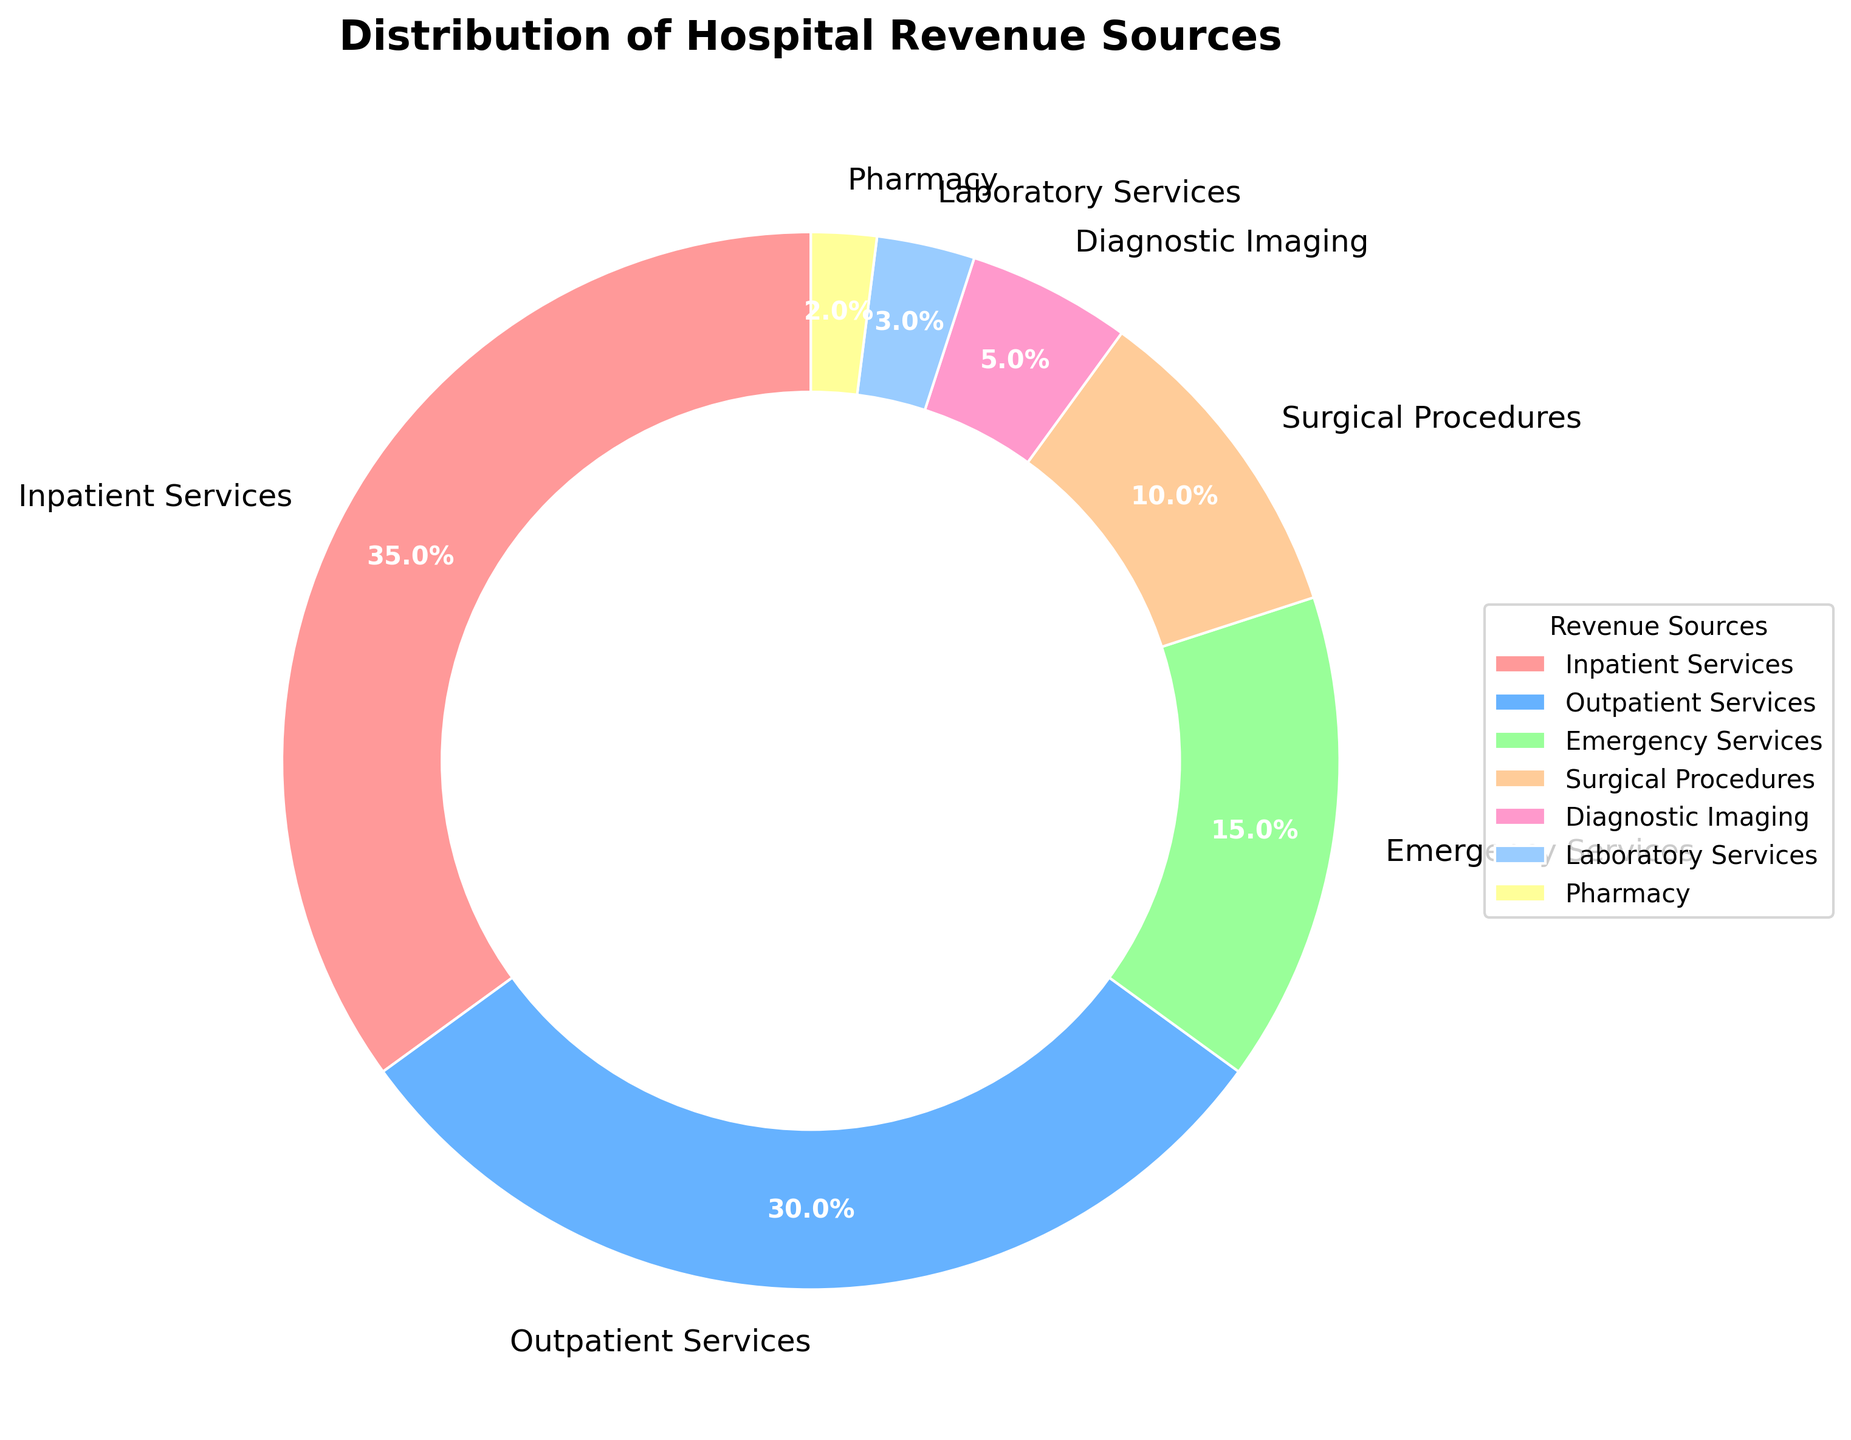What percentage of hospital revenue comes from inpatient services and surgical procedures combined? To find the combined percentage of revenue from inpatient services and surgical procedures, add their individual percentages: 35% (inpatient services) + 10% (surgical procedures) = 45%.
Answer: 45% Which revenue source contributes less to the total revenue: laboratory services or pharmacy? The pie chart shows that laboratory services contribute 3% and pharmacy contributes 2%. Since 2% is less than 3%, pharmacy contributes less.
Answer: Pharmacy What is the difference in the revenue percentage between outpatient services and emergency services? Subtract the percentage of emergency services from the percentage of outpatient services: 30% (outpatient services) - 15% (emergency services) = 15%.
Answer: 15% Which segment has the smallest contribution to hospital revenue? The pie chart shows that the smallest segment is pharmacy, with a contribution of 2%.
Answer: Pharmacy Together, how much revenue is generated from diagnostic imaging, laboratory services, and pharmacy? Add the percentages of diagnostic imaging, laboratory services, and pharmacy: 5% (diagnostic imaging) + 3% (laboratory services) + 2% (pharmacy) = 10%.
Answer: 10% Compare the revenue contributions of emergency services and surgical procedures. Which one is higher, and by how much? The pie chart shows emergency services at 15% and surgical procedures at 10%. Emergency services are higher. The difference is 15% - 10% = 5%.
Answer: Emergency services, by 5% What color represents inpatient services on the pie chart? The inpatient services segment is represented by the red color on the pie chart.
Answer: Red If the total revenue for the hospital is $1,000,000, how much revenue is generated from outpatient services? Calculate 30% of $1,000,000 by multiplying 1,000,000 by 0.30, which equals $300,000.
Answer: $300,000 What is the total percentage of revenue generated from services other than inpatient and outpatient services? Sum the percentages of emergency services, surgical procedures, diagnostic imaging, laboratory services, and pharmacy: 15% + 10% + 5% + 3% + 2% = 35%.
Answer: 35% Is the revenue contribution from emergency services more than half of that from inpatient services? Calculate half of the inpatient services' percentage: 35% / 2 = 17.5%. Since emergency services contribute 15%, which is less than 17.5%, emergency services contribute less than half of inpatient services.
Answer: No 